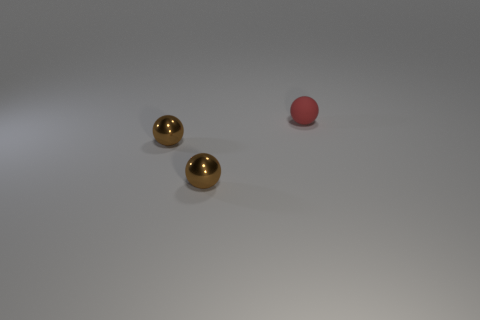Is there anything else that is made of the same material as the tiny red thing?
Your response must be concise. No. How many objects are either tiny objects left of the rubber ball or large gray balls?
Your answer should be very brief. 2. What is the size of the matte object?
Provide a succinct answer. Small. What number of rubber spheres are the same size as the red object?
Provide a succinct answer. 0. Is the number of big purple matte balls less than the number of brown objects?
Ensure brevity in your answer.  Yes. What number of tiny metallic things are the same shape as the red matte thing?
Make the answer very short. 2. Are there any large cyan metal blocks?
Make the answer very short. No. Are there any red blocks that have the same material as the red sphere?
Keep it short and to the point. No. What number of brown things are there?
Your answer should be very brief. 2. What number of things are to the right of the tiny matte object?
Offer a terse response. 0. 